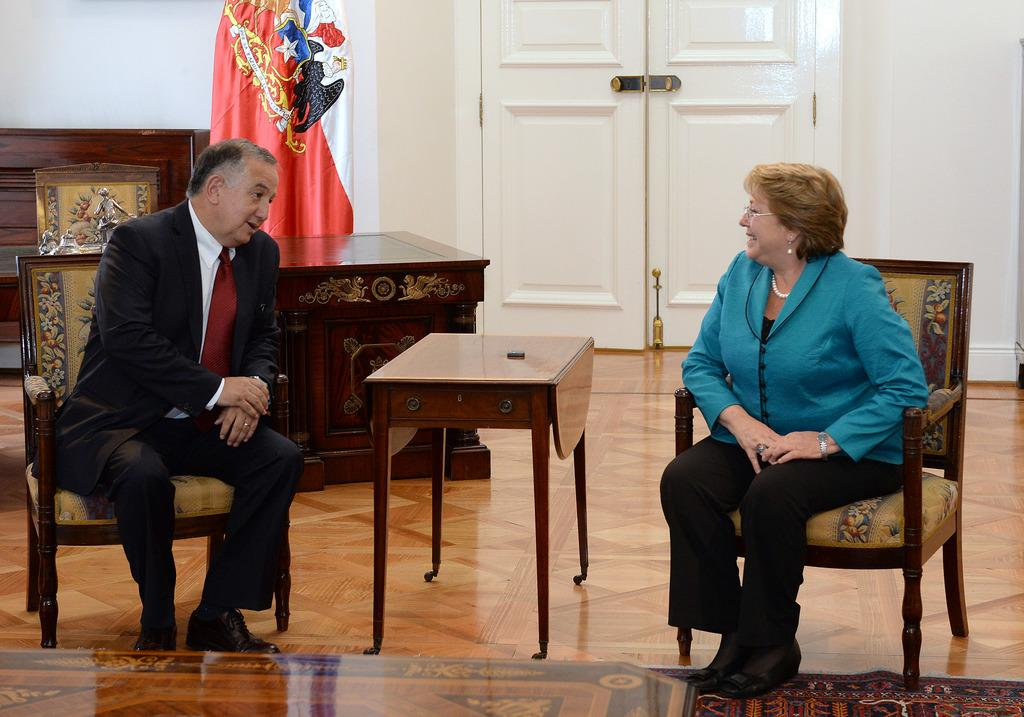What types of people are in the image? There are men and women in the image. What are the men and women doing in the image? The men and women are sitting on chairs and talking to each other. What is in front of the chairs? There is a table in front of the chairs. What can be seen in the background of the image? There is a flag visible in the background and a door present in the background. What type of fiction is the group reading in the image? There is no fiction present in the image; the men and women are talking to each other. How many oranges are on the table in the image? There are no oranges present in the image; the table has other items on it. 